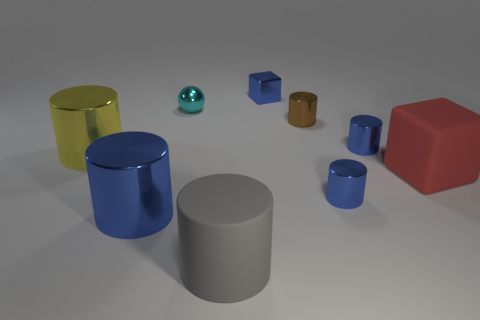Subtract all gray balls. How many blue cylinders are left? 3 Subtract all brown cylinders. How many cylinders are left? 5 Subtract all rubber cylinders. How many cylinders are left? 5 Subtract all gray cylinders. Subtract all yellow blocks. How many cylinders are left? 5 Subtract all cubes. How many objects are left? 7 Add 1 small blue cylinders. How many small blue cylinders are left? 3 Add 2 blue shiny cubes. How many blue shiny cubes exist? 3 Subtract 0 gray cubes. How many objects are left? 9 Subtract all large gray objects. Subtract all yellow metal cylinders. How many objects are left? 7 